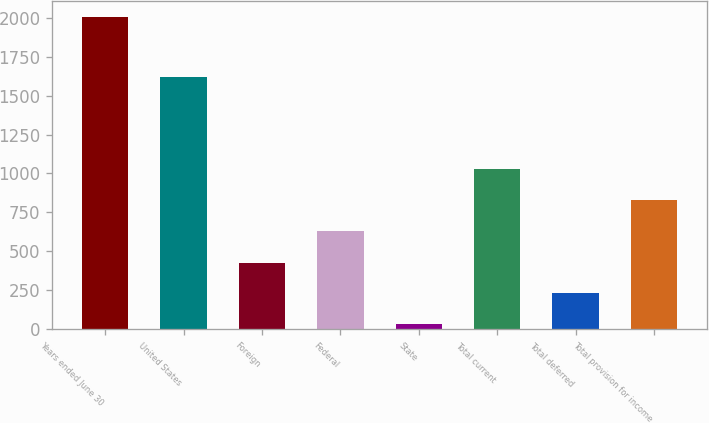Convert chart to OTSL. <chart><loc_0><loc_0><loc_500><loc_500><bar_chart><fcel>Years ended June 30<fcel>United States<fcel>Foreign<fcel>Federal<fcel>State<fcel>Total current<fcel>Total deferred<fcel>Total provision for income<nl><fcel>2008<fcel>1618.6<fcel>426.8<fcel>632.3<fcel>31.5<fcel>1027.6<fcel>229.15<fcel>829.95<nl></chart> 